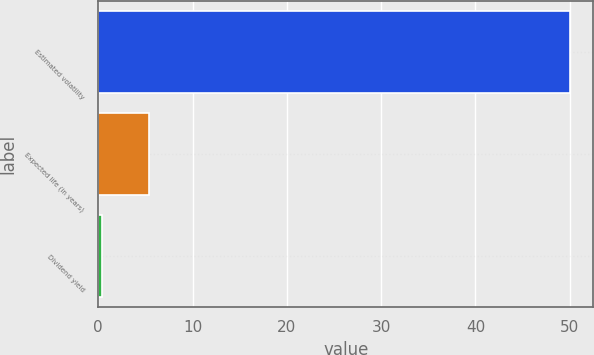Convert chart to OTSL. <chart><loc_0><loc_0><loc_500><loc_500><bar_chart><fcel>Estimated volatility<fcel>Expected life (in years)<fcel>Dividend yield<nl><fcel>50<fcel>5.41<fcel>0.45<nl></chart> 